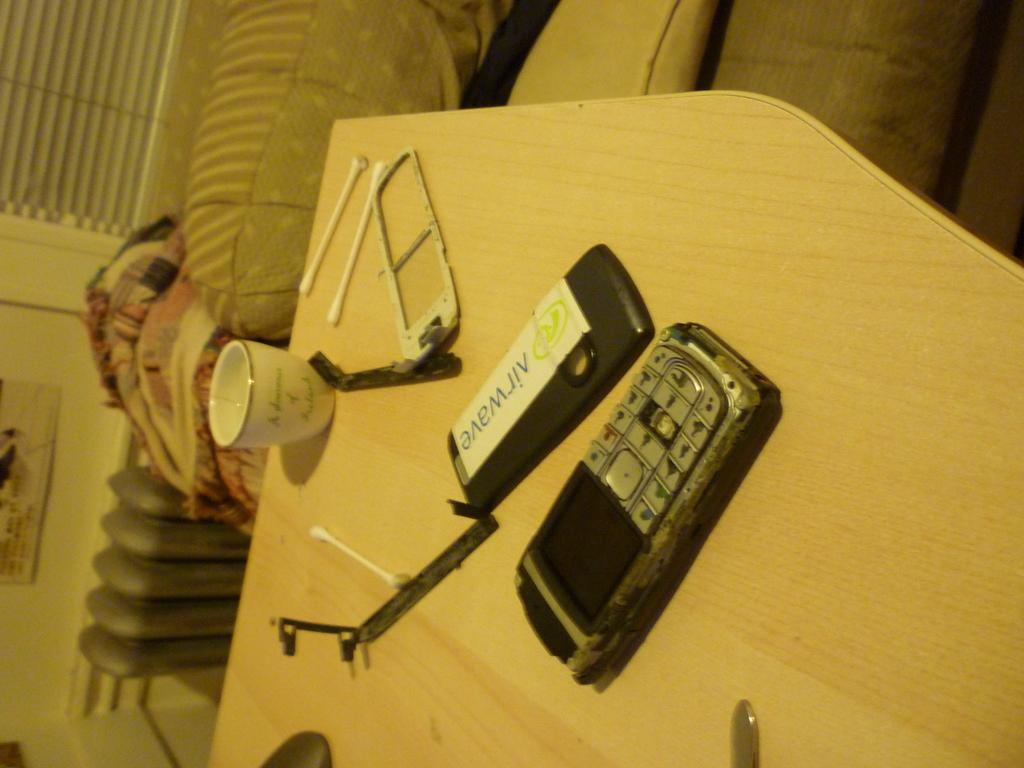<image>
Give a short and clear explanation of the subsequent image. Broken cellphone next to a device that says "Airwave". 